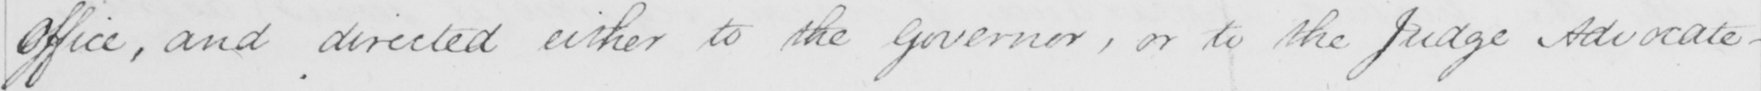What is written in this line of handwriting? Office , and directed either to the Governor , or to the Judge Advocate _ 